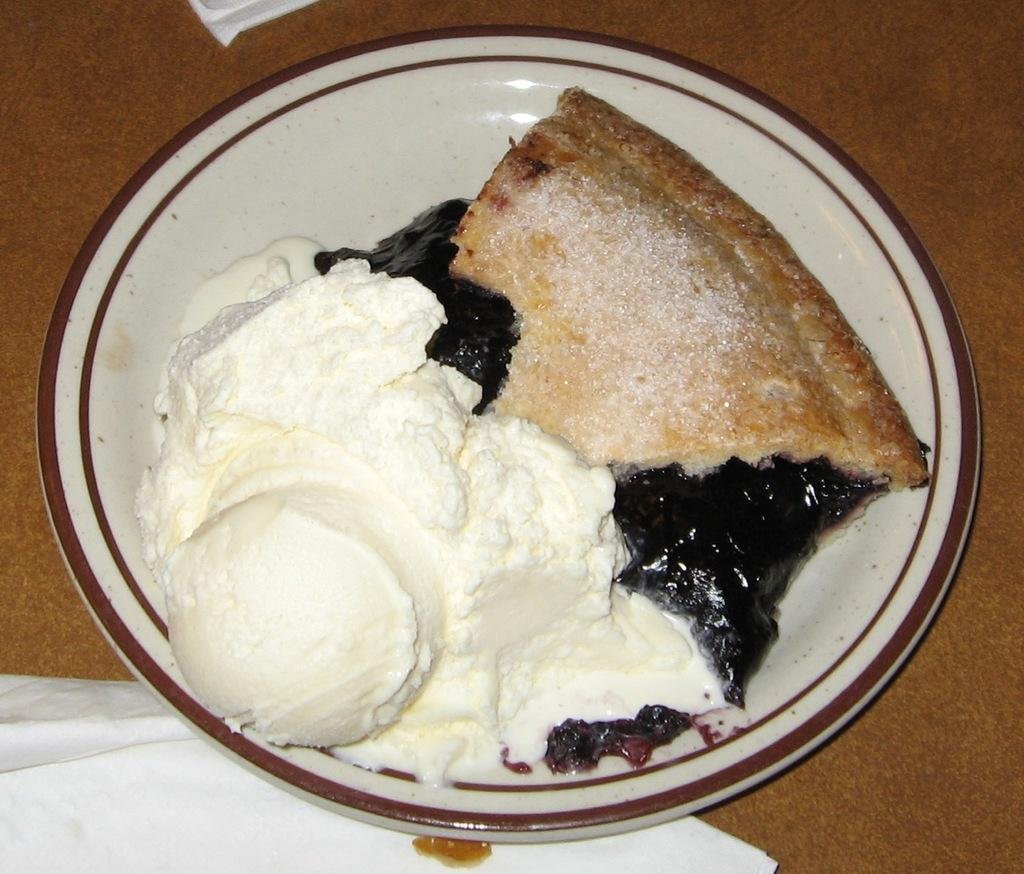What is on the plate that is visible in the image? There is a plate with food items in the image. What is the plate placed on? The plate is placed on a wooden surface. What can be used for cleaning or wiping in the image? Tissue papers are present in the image for cleaning or wiping. Which direction is the duck facing in the image? There is no duck present in the image. What type of drink is being served with the food in the image? The image does not show any drinks; it only shows a plate with food items. 